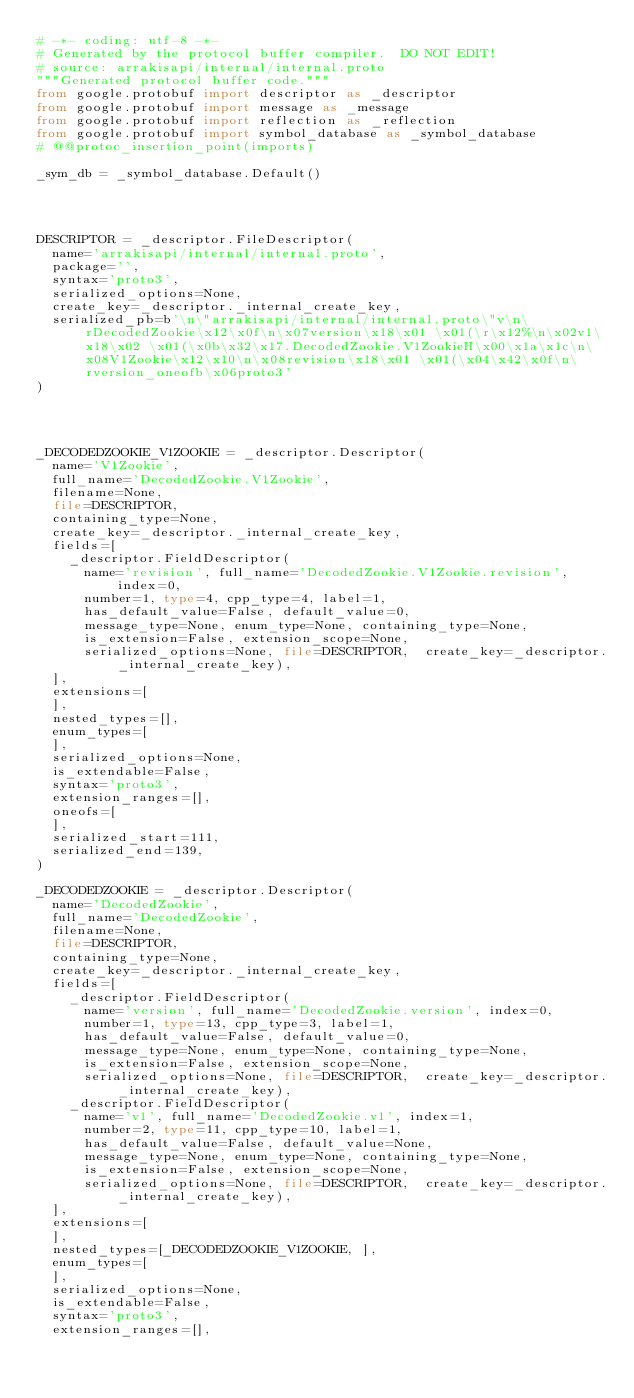<code> <loc_0><loc_0><loc_500><loc_500><_Python_># -*- coding: utf-8 -*-
# Generated by the protocol buffer compiler.  DO NOT EDIT!
# source: arrakisapi/internal/internal.proto
"""Generated protocol buffer code."""
from google.protobuf import descriptor as _descriptor
from google.protobuf import message as _message
from google.protobuf import reflection as _reflection
from google.protobuf import symbol_database as _symbol_database
# @@protoc_insertion_point(imports)

_sym_db = _symbol_database.Default()




DESCRIPTOR = _descriptor.FileDescriptor(
  name='arrakisapi/internal/internal.proto',
  package='',
  syntax='proto3',
  serialized_options=None,
  create_key=_descriptor._internal_create_key,
  serialized_pb=b'\n\"arrakisapi/internal/internal.proto\"v\n\rDecodedZookie\x12\x0f\n\x07version\x18\x01 \x01(\r\x12%\n\x02v1\x18\x02 \x01(\x0b\x32\x17.DecodedZookie.V1ZookieH\x00\x1a\x1c\n\x08V1Zookie\x12\x10\n\x08revision\x18\x01 \x01(\x04\x42\x0f\n\rversion_oneofb\x06proto3'
)




_DECODEDZOOKIE_V1ZOOKIE = _descriptor.Descriptor(
  name='V1Zookie',
  full_name='DecodedZookie.V1Zookie',
  filename=None,
  file=DESCRIPTOR,
  containing_type=None,
  create_key=_descriptor._internal_create_key,
  fields=[
    _descriptor.FieldDescriptor(
      name='revision', full_name='DecodedZookie.V1Zookie.revision', index=0,
      number=1, type=4, cpp_type=4, label=1,
      has_default_value=False, default_value=0,
      message_type=None, enum_type=None, containing_type=None,
      is_extension=False, extension_scope=None,
      serialized_options=None, file=DESCRIPTOR,  create_key=_descriptor._internal_create_key),
  ],
  extensions=[
  ],
  nested_types=[],
  enum_types=[
  ],
  serialized_options=None,
  is_extendable=False,
  syntax='proto3',
  extension_ranges=[],
  oneofs=[
  ],
  serialized_start=111,
  serialized_end=139,
)

_DECODEDZOOKIE = _descriptor.Descriptor(
  name='DecodedZookie',
  full_name='DecodedZookie',
  filename=None,
  file=DESCRIPTOR,
  containing_type=None,
  create_key=_descriptor._internal_create_key,
  fields=[
    _descriptor.FieldDescriptor(
      name='version', full_name='DecodedZookie.version', index=0,
      number=1, type=13, cpp_type=3, label=1,
      has_default_value=False, default_value=0,
      message_type=None, enum_type=None, containing_type=None,
      is_extension=False, extension_scope=None,
      serialized_options=None, file=DESCRIPTOR,  create_key=_descriptor._internal_create_key),
    _descriptor.FieldDescriptor(
      name='v1', full_name='DecodedZookie.v1', index=1,
      number=2, type=11, cpp_type=10, label=1,
      has_default_value=False, default_value=None,
      message_type=None, enum_type=None, containing_type=None,
      is_extension=False, extension_scope=None,
      serialized_options=None, file=DESCRIPTOR,  create_key=_descriptor._internal_create_key),
  ],
  extensions=[
  ],
  nested_types=[_DECODEDZOOKIE_V1ZOOKIE, ],
  enum_types=[
  ],
  serialized_options=None,
  is_extendable=False,
  syntax='proto3',
  extension_ranges=[],</code> 